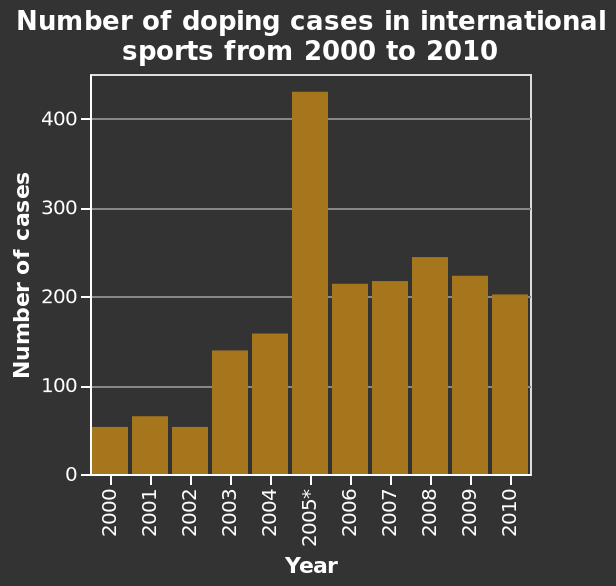<image>
How does the number of doping cases in 2005 compare to other years?  The number of doping cases in 2005 was double that of any other year after that. Which years had more doping cases than the year 2005? No year had more doping cases than the year 2005; it had the highest number of cases recorded. What does the bar graph depict? The bar graph depicts the number of doping cases in international sports from 2000 to 2010. Offer a thorough analysis of the image. 2005 has doubled the number of doping cases than any other year after that with the second highest being 240 in 2008 and 50 as the lowest in 2000. 